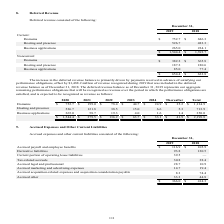From Godaddy's financial document, What are the 3 types of non-current deferred revenue? The document contains multiple relevant values: Domains, Hosting and presence, Business applications. From the document: "$ 752.7 $ 686.3 Hosting and presence 526.7 483.3 Business applications 265.0 224.1 er 31, 2019 2018 Current: Domains $ 752.7 $ 686.3 Hosting and prese..." Also, What is the 2019 year end total non-current deferred revenue? According to the financial document, 654.4. The relevant text states: "$ 654.4 $ 623.8..." Also, What is the 2018 year end total non-current deferred revenue? According to the financial document, 623.8. The relevant text states: "$ 654.4 $ 623.8..." Also, can you calculate: What is the average total current deferred revenue for 2018 and 2019? To answer this question, I need to perform calculations using the financial data. The calculation is: (1,544.4+1,393.7)/2, which equals 1469.05. This is based on the information: "$ 1,544.4 $ 1,393.7 Noncurrent: Domains $ 382.2 $ 365.8 Hosting and presence 187.2 180.6 Business applications 85.0 77. $ 1,544.4 $ 1,393.7 Noncurrent: Domains $ 382.2 $ 365.8 Hosting and presence 187..." The key data points involved are: 1,393.7, 1,544.4. Also, can you calculate: What is the average total non-current deferred revenue for 2018 and 2019? To answer this question, I need to perform calculations using the financial data. The calculation is: (654.4+623.8)/2, which equals 639.1. This is based on the information: "$ 654.4 $ 623.8 $ 654.4 $ 623.8..." The key data points involved are: 623.8, 654.4. Additionally, Was total current or total non-current deferred revenue greater for 2019 year end? According to the financial document, Current. The relevant text states: "December 31, 2019 2018 Current: Domains $ 752.7 $ 686.3 Hosting and presence 526.7 483.3 Business applications 265.0 224.1..." 